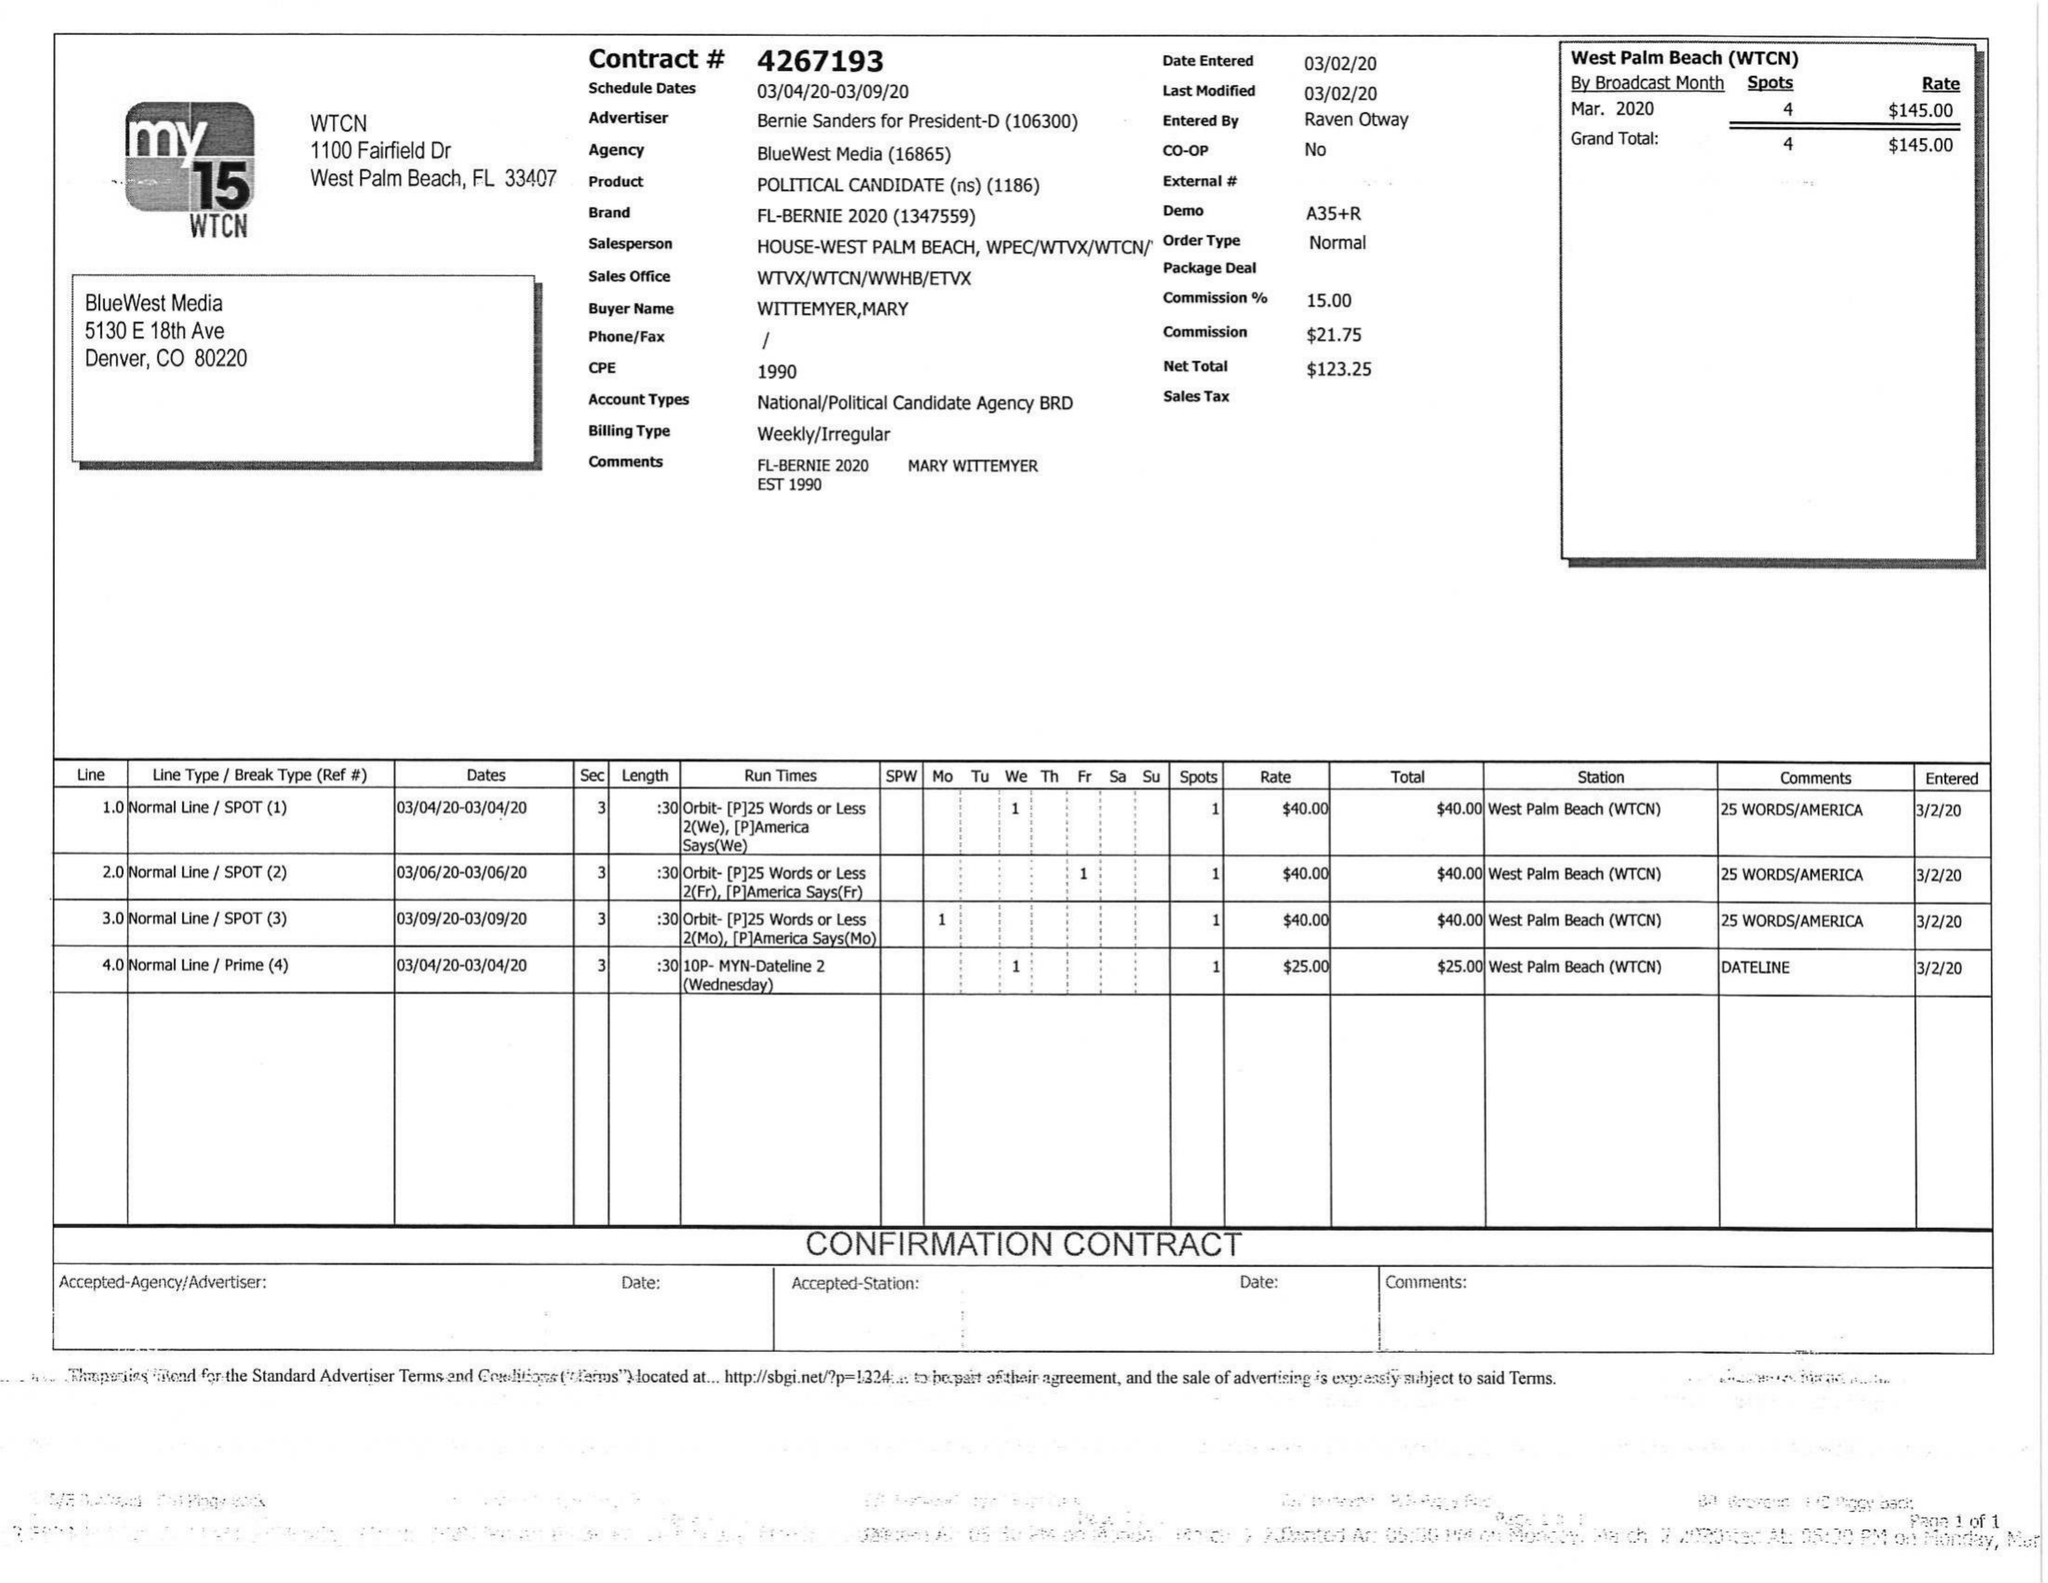What is the value for the flight_to?
Answer the question using a single word or phrase. 03/09/20 